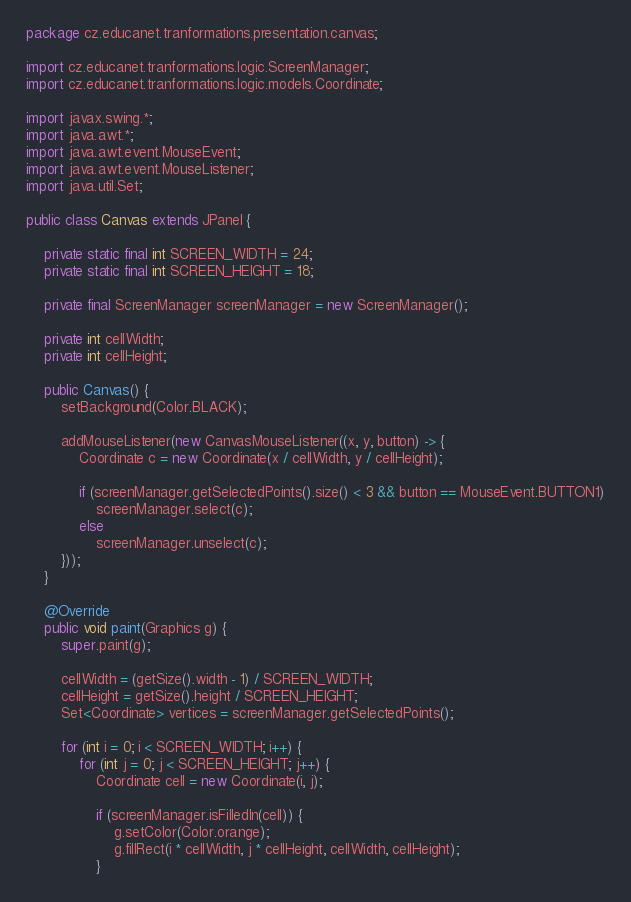<code> <loc_0><loc_0><loc_500><loc_500><_Java_>package cz.educanet.tranformations.presentation.canvas;

import cz.educanet.tranformations.logic.ScreenManager;
import cz.educanet.tranformations.logic.models.Coordinate;

import javax.swing.*;
import java.awt.*;
import java.awt.event.MouseEvent;
import java.awt.event.MouseListener;
import java.util.Set;

public class Canvas extends JPanel {

    private static final int SCREEN_WIDTH = 24;
    private static final int SCREEN_HEIGHT = 18;

    private final ScreenManager screenManager = new ScreenManager();

    private int cellWidth;
    private int cellHeight;

    public Canvas() {
        setBackground(Color.BLACK);

        addMouseListener(new CanvasMouseListener((x, y, button) -> {
            Coordinate c = new Coordinate(x / cellWidth, y / cellHeight);

            if (screenManager.getSelectedPoints().size() < 3 && button == MouseEvent.BUTTON1)
                screenManager.select(c);
            else
                screenManager.unselect(c);
        }));
    }

    @Override
    public void paint(Graphics g) {
        super.paint(g);

        cellWidth = (getSize().width - 1) / SCREEN_WIDTH;
        cellHeight = getSize().height / SCREEN_HEIGHT;
        Set<Coordinate> vertices = screenManager.getSelectedPoints();

        for (int i = 0; i < SCREEN_WIDTH; i++) {
            for (int j = 0; j < SCREEN_HEIGHT; j++) {
                Coordinate cell = new Coordinate(i, j);

                if (screenManager.isFilledIn(cell)) {
                    g.setColor(Color.orange);
                    g.fillRect(i * cellWidth, j * cellHeight, cellWidth, cellHeight);
                }
</code> 